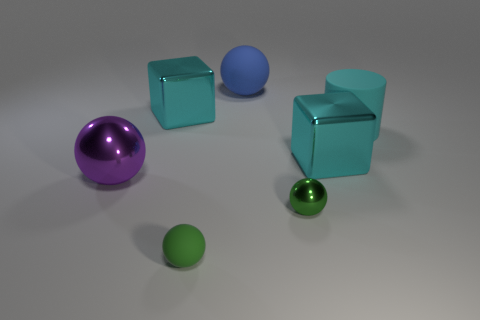Add 1 tiny shiny balls. How many objects exist? 8 Subtract all spheres. How many objects are left? 3 Add 1 big shiny cylinders. How many big shiny cylinders exist? 1 Subtract 0 yellow blocks. How many objects are left? 7 Subtract all big blue cylinders. Subtract all blue rubber spheres. How many objects are left? 6 Add 4 matte balls. How many matte balls are left? 6 